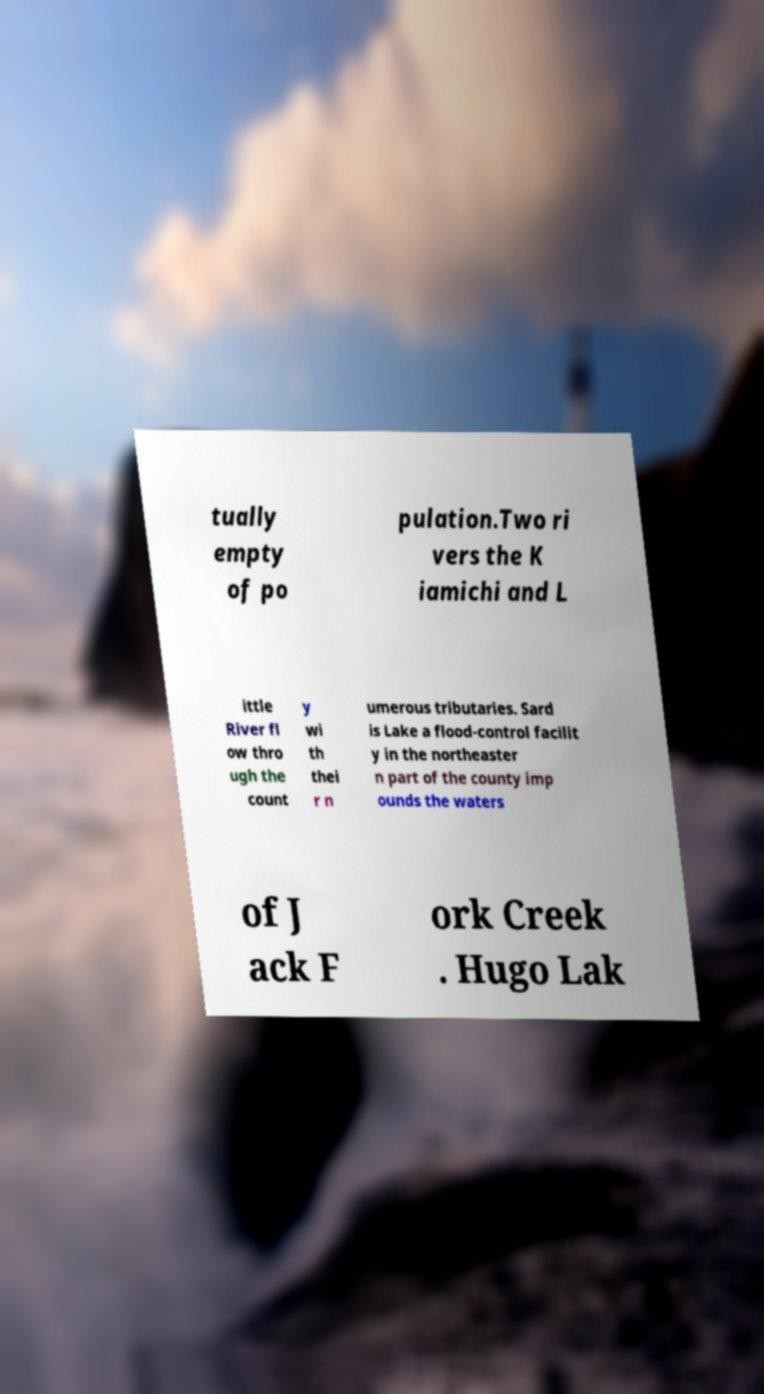I need the written content from this picture converted into text. Can you do that? tually empty of po pulation.Two ri vers the K iamichi and L ittle River fl ow thro ugh the count y wi th thei r n umerous tributaries. Sard is Lake a flood-control facilit y in the northeaster n part of the county imp ounds the waters of J ack F ork Creek . Hugo Lak 